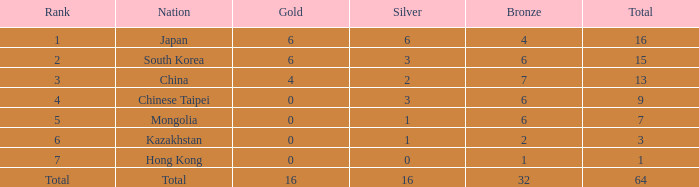Which is the lowest bronze that holds a rank of 3 and has a silver smaller than 2? None. 